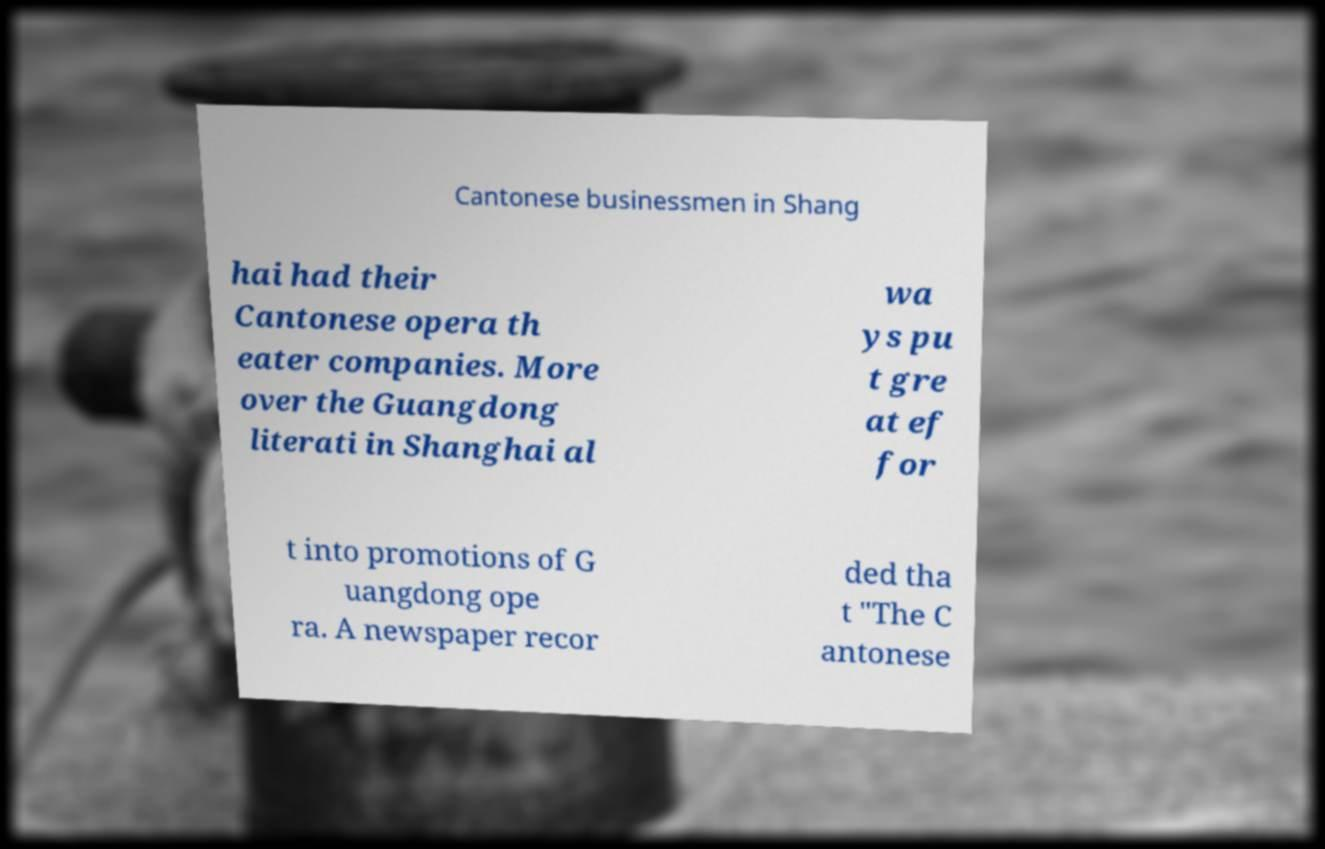What messages or text are displayed in this image? I need them in a readable, typed format. Cantonese businessmen in Shang hai had their Cantonese opera th eater companies. More over the Guangdong literati in Shanghai al wa ys pu t gre at ef for t into promotions of G uangdong ope ra. A newspaper recor ded tha t "The C antonese 